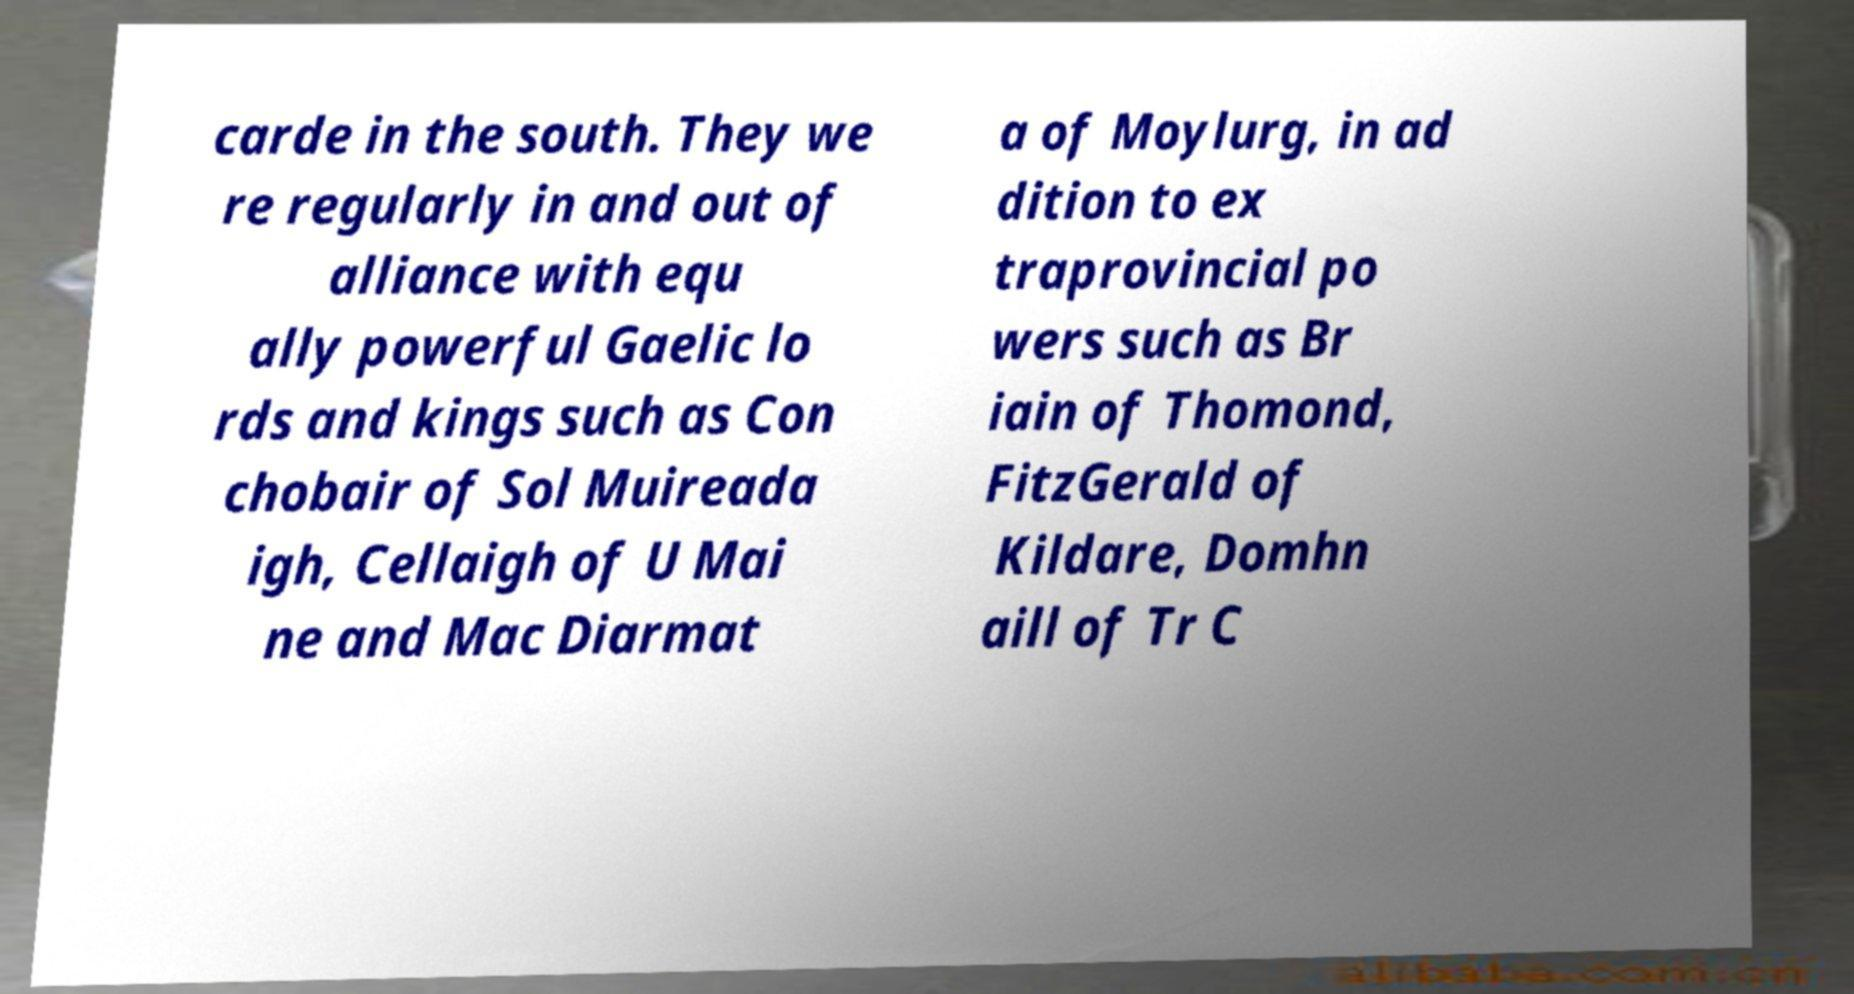Can you read and provide the text displayed in the image?This photo seems to have some interesting text. Can you extract and type it out for me? carde in the south. They we re regularly in and out of alliance with equ ally powerful Gaelic lo rds and kings such as Con chobair of Sol Muireada igh, Cellaigh of U Mai ne and Mac Diarmat a of Moylurg, in ad dition to ex traprovincial po wers such as Br iain of Thomond, FitzGerald of Kildare, Domhn aill of Tr C 